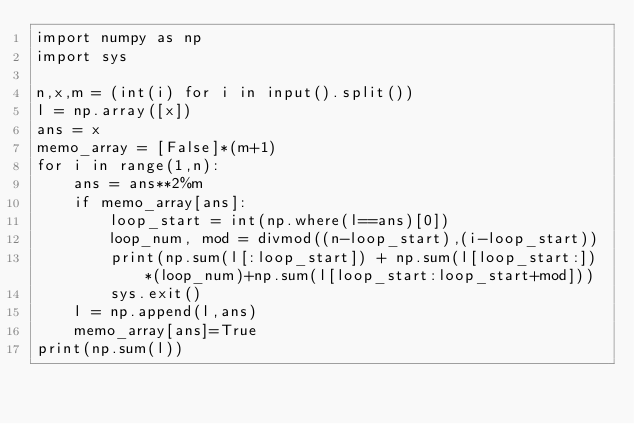Convert code to text. <code><loc_0><loc_0><loc_500><loc_500><_Python_>import numpy as np
import sys

n,x,m = (int(i) for i in input().split())
l = np.array([x])
ans = x
memo_array = [False]*(m+1)
for i in range(1,n):
    ans = ans**2%m
    if memo_array[ans]:
        loop_start = int(np.where(l==ans)[0])
        loop_num, mod = divmod((n-loop_start),(i-loop_start))
        print(np.sum(l[:loop_start]) + np.sum(l[loop_start:])*(loop_num)+np.sum(l[loop_start:loop_start+mod]))
        sys.exit()
    l = np.append(l,ans)
    memo_array[ans]=True
print(np.sum(l))</code> 